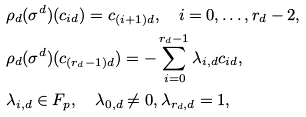<formula> <loc_0><loc_0><loc_500><loc_500>& \rho _ { d } ( \sigma ^ { d } ) ( c _ { i d } ) = c _ { ( i + 1 ) d } , \quad i = 0 , \dots , r _ { d } - 2 , \\ & \rho _ { d } ( \sigma ^ { d } ) ( c _ { ( r _ { d } - 1 ) d } ) = - \sum _ { i = 0 } ^ { r _ { d } - 1 } \lambda _ { i , d } c _ { i d } , \\ & \lambda _ { i , d } \in { F } _ { p } , \quad \lambda _ { 0 , d } \not = 0 , \lambda _ { r _ { d } , d } = 1 ,</formula> 